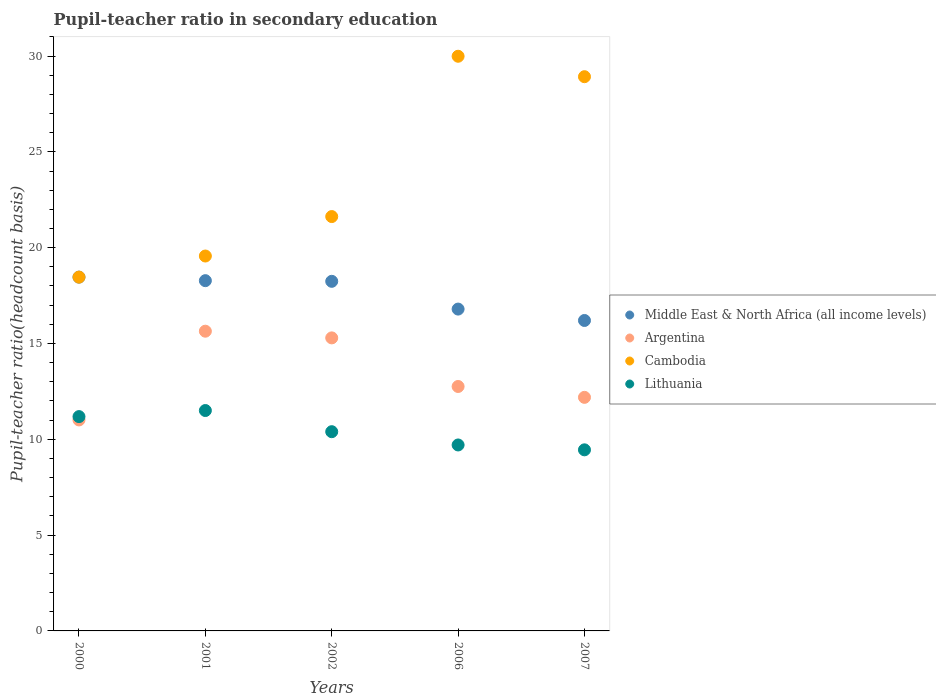How many different coloured dotlines are there?
Keep it short and to the point. 4. What is the pupil-teacher ratio in secondary education in Middle East & North Africa (all income levels) in 2001?
Keep it short and to the point. 18.28. Across all years, what is the maximum pupil-teacher ratio in secondary education in Lithuania?
Ensure brevity in your answer.  11.5. Across all years, what is the minimum pupil-teacher ratio in secondary education in Lithuania?
Keep it short and to the point. 9.45. In which year was the pupil-teacher ratio in secondary education in Cambodia minimum?
Provide a short and direct response. 2000. What is the total pupil-teacher ratio in secondary education in Cambodia in the graph?
Your response must be concise. 118.56. What is the difference between the pupil-teacher ratio in secondary education in Middle East & North Africa (all income levels) in 2002 and that in 2007?
Keep it short and to the point. 2.04. What is the difference between the pupil-teacher ratio in secondary education in Lithuania in 2001 and the pupil-teacher ratio in secondary education in Middle East & North Africa (all income levels) in 2000?
Your answer should be very brief. -6.96. What is the average pupil-teacher ratio in secondary education in Middle East & North Africa (all income levels) per year?
Offer a terse response. 17.6. In the year 2001, what is the difference between the pupil-teacher ratio in secondary education in Cambodia and pupil-teacher ratio in secondary education in Argentina?
Your response must be concise. 3.92. What is the ratio of the pupil-teacher ratio in secondary education in Lithuania in 2000 to that in 2007?
Offer a very short reply. 1.18. Is the difference between the pupil-teacher ratio in secondary education in Cambodia in 2000 and 2006 greater than the difference between the pupil-teacher ratio in secondary education in Argentina in 2000 and 2006?
Give a very brief answer. No. What is the difference between the highest and the second highest pupil-teacher ratio in secondary education in Middle East & North Africa (all income levels)?
Make the answer very short. 0.18. What is the difference between the highest and the lowest pupil-teacher ratio in secondary education in Lithuania?
Make the answer very short. 2.05. Is the sum of the pupil-teacher ratio in secondary education in Cambodia in 2000 and 2006 greater than the maximum pupil-teacher ratio in secondary education in Middle East & North Africa (all income levels) across all years?
Give a very brief answer. Yes. Is it the case that in every year, the sum of the pupil-teacher ratio in secondary education in Lithuania and pupil-teacher ratio in secondary education in Cambodia  is greater than the pupil-teacher ratio in secondary education in Argentina?
Offer a very short reply. Yes. Does the pupil-teacher ratio in secondary education in Middle East & North Africa (all income levels) monotonically increase over the years?
Offer a terse response. No. Is the pupil-teacher ratio in secondary education in Cambodia strictly greater than the pupil-teacher ratio in secondary education in Argentina over the years?
Provide a short and direct response. Yes. Is the pupil-teacher ratio in secondary education in Middle East & North Africa (all income levels) strictly less than the pupil-teacher ratio in secondary education in Argentina over the years?
Your response must be concise. No. How many dotlines are there?
Offer a terse response. 4. How many years are there in the graph?
Give a very brief answer. 5. What is the difference between two consecutive major ticks on the Y-axis?
Your answer should be compact. 5. Are the values on the major ticks of Y-axis written in scientific E-notation?
Provide a short and direct response. No. Does the graph contain grids?
Your answer should be compact. No. Where does the legend appear in the graph?
Your answer should be compact. Center right. How are the legend labels stacked?
Give a very brief answer. Vertical. What is the title of the graph?
Your answer should be compact. Pupil-teacher ratio in secondary education. Does "Mozambique" appear as one of the legend labels in the graph?
Offer a terse response. No. What is the label or title of the X-axis?
Your answer should be compact. Years. What is the label or title of the Y-axis?
Ensure brevity in your answer.  Pupil-teacher ratio(headcount basis). What is the Pupil-teacher ratio(headcount basis) of Middle East & North Africa (all income levels) in 2000?
Keep it short and to the point. 18.46. What is the Pupil-teacher ratio(headcount basis) of Argentina in 2000?
Provide a succinct answer. 11.01. What is the Pupil-teacher ratio(headcount basis) in Cambodia in 2000?
Provide a short and direct response. 18.46. What is the Pupil-teacher ratio(headcount basis) of Lithuania in 2000?
Make the answer very short. 11.18. What is the Pupil-teacher ratio(headcount basis) in Middle East & North Africa (all income levels) in 2001?
Provide a succinct answer. 18.28. What is the Pupil-teacher ratio(headcount basis) of Argentina in 2001?
Ensure brevity in your answer.  15.64. What is the Pupil-teacher ratio(headcount basis) in Cambodia in 2001?
Provide a succinct answer. 19.56. What is the Pupil-teacher ratio(headcount basis) of Lithuania in 2001?
Ensure brevity in your answer.  11.5. What is the Pupil-teacher ratio(headcount basis) of Middle East & North Africa (all income levels) in 2002?
Give a very brief answer. 18.24. What is the Pupil-teacher ratio(headcount basis) in Argentina in 2002?
Ensure brevity in your answer.  15.29. What is the Pupil-teacher ratio(headcount basis) in Cambodia in 2002?
Offer a terse response. 21.62. What is the Pupil-teacher ratio(headcount basis) in Lithuania in 2002?
Offer a terse response. 10.4. What is the Pupil-teacher ratio(headcount basis) of Middle East & North Africa (all income levels) in 2006?
Offer a terse response. 16.8. What is the Pupil-teacher ratio(headcount basis) in Argentina in 2006?
Provide a short and direct response. 12.76. What is the Pupil-teacher ratio(headcount basis) of Cambodia in 2006?
Keep it short and to the point. 29.99. What is the Pupil-teacher ratio(headcount basis) of Lithuania in 2006?
Provide a succinct answer. 9.7. What is the Pupil-teacher ratio(headcount basis) in Middle East & North Africa (all income levels) in 2007?
Provide a short and direct response. 16.2. What is the Pupil-teacher ratio(headcount basis) in Argentina in 2007?
Make the answer very short. 12.19. What is the Pupil-teacher ratio(headcount basis) of Cambodia in 2007?
Provide a succinct answer. 28.92. What is the Pupil-teacher ratio(headcount basis) of Lithuania in 2007?
Make the answer very short. 9.45. Across all years, what is the maximum Pupil-teacher ratio(headcount basis) in Middle East & North Africa (all income levels)?
Your response must be concise. 18.46. Across all years, what is the maximum Pupil-teacher ratio(headcount basis) of Argentina?
Offer a terse response. 15.64. Across all years, what is the maximum Pupil-teacher ratio(headcount basis) in Cambodia?
Provide a succinct answer. 29.99. Across all years, what is the maximum Pupil-teacher ratio(headcount basis) of Lithuania?
Your answer should be compact. 11.5. Across all years, what is the minimum Pupil-teacher ratio(headcount basis) of Middle East & North Africa (all income levels)?
Provide a short and direct response. 16.2. Across all years, what is the minimum Pupil-teacher ratio(headcount basis) of Argentina?
Make the answer very short. 11.01. Across all years, what is the minimum Pupil-teacher ratio(headcount basis) of Cambodia?
Make the answer very short. 18.46. Across all years, what is the minimum Pupil-teacher ratio(headcount basis) in Lithuania?
Ensure brevity in your answer.  9.45. What is the total Pupil-teacher ratio(headcount basis) in Middle East & North Africa (all income levels) in the graph?
Your answer should be compact. 87.98. What is the total Pupil-teacher ratio(headcount basis) in Argentina in the graph?
Your response must be concise. 66.89. What is the total Pupil-teacher ratio(headcount basis) of Cambodia in the graph?
Your response must be concise. 118.56. What is the total Pupil-teacher ratio(headcount basis) in Lithuania in the graph?
Make the answer very short. 52.24. What is the difference between the Pupil-teacher ratio(headcount basis) of Middle East & North Africa (all income levels) in 2000 and that in 2001?
Provide a succinct answer. 0.18. What is the difference between the Pupil-teacher ratio(headcount basis) of Argentina in 2000 and that in 2001?
Offer a very short reply. -4.63. What is the difference between the Pupil-teacher ratio(headcount basis) in Cambodia in 2000 and that in 2001?
Keep it short and to the point. -1.1. What is the difference between the Pupil-teacher ratio(headcount basis) in Lithuania in 2000 and that in 2001?
Your answer should be compact. -0.32. What is the difference between the Pupil-teacher ratio(headcount basis) in Middle East & North Africa (all income levels) in 2000 and that in 2002?
Your answer should be very brief. 0.22. What is the difference between the Pupil-teacher ratio(headcount basis) in Argentina in 2000 and that in 2002?
Your response must be concise. -4.28. What is the difference between the Pupil-teacher ratio(headcount basis) of Cambodia in 2000 and that in 2002?
Your answer should be compact. -3.16. What is the difference between the Pupil-teacher ratio(headcount basis) in Lithuania in 2000 and that in 2002?
Offer a terse response. 0.79. What is the difference between the Pupil-teacher ratio(headcount basis) in Middle East & North Africa (all income levels) in 2000 and that in 2006?
Offer a terse response. 1.67. What is the difference between the Pupil-teacher ratio(headcount basis) of Argentina in 2000 and that in 2006?
Your answer should be very brief. -1.75. What is the difference between the Pupil-teacher ratio(headcount basis) in Cambodia in 2000 and that in 2006?
Provide a short and direct response. -11.53. What is the difference between the Pupil-teacher ratio(headcount basis) of Lithuania in 2000 and that in 2006?
Your answer should be compact. 1.48. What is the difference between the Pupil-teacher ratio(headcount basis) of Middle East & North Africa (all income levels) in 2000 and that in 2007?
Your answer should be very brief. 2.26. What is the difference between the Pupil-teacher ratio(headcount basis) of Argentina in 2000 and that in 2007?
Your answer should be very brief. -1.18. What is the difference between the Pupil-teacher ratio(headcount basis) of Cambodia in 2000 and that in 2007?
Keep it short and to the point. -10.46. What is the difference between the Pupil-teacher ratio(headcount basis) in Lithuania in 2000 and that in 2007?
Ensure brevity in your answer.  1.73. What is the difference between the Pupil-teacher ratio(headcount basis) of Middle East & North Africa (all income levels) in 2001 and that in 2002?
Offer a very short reply. 0.03. What is the difference between the Pupil-teacher ratio(headcount basis) of Argentina in 2001 and that in 2002?
Provide a short and direct response. 0.35. What is the difference between the Pupil-teacher ratio(headcount basis) in Cambodia in 2001 and that in 2002?
Your answer should be compact. -2.06. What is the difference between the Pupil-teacher ratio(headcount basis) of Lithuania in 2001 and that in 2002?
Provide a short and direct response. 1.1. What is the difference between the Pupil-teacher ratio(headcount basis) in Middle East & North Africa (all income levels) in 2001 and that in 2006?
Make the answer very short. 1.48. What is the difference between the Pupil-teacher ratio(headcount basis) of Argentina in 2001 and that in 2006?
Your answer should be compact. 2.88. What is the difference between the Pupil-teacher ratio(headcount basis) of Cambodia in 2001 and that in 2006?
Give a very brief answer. -10.42. What is the difference between the Pupil-teacher ratio(headcount basis) of Lithuania in 2001 and that in 2006?
Your response must be concise. 1.8. What is the difference between the Pupil-teacher ratio(headcount basis) in Middle East & North Africa (all income levels) in 2001 and that in 2007?
Offer a very short reply. 2.08. What is the difference between the Pupil-teacher ratio(headcount basis) of Argentina in 2001 and that in 2007?
Give a very brief answer. 3.45. What is the difference between the Pupil-teacher ratio(headcount basis) in Cambodia in 2001 and that in 2007?
Make the answer very short. -9.36. What is the difference between the Pupil-teacher ratio(headcount basis) in Lithuania in 2001 and that in 2007?
Provide a short and direct response. 2.05. What is the difference between the Pupil-teacher ratio(headcount basis) in Middle East & North Africa (all income levels) in 2002 and that in 2006?
Offer a terse response. 1.45. What is the difference between the Pupil-teacher ratio(headcount basis) of Argentina in 2002 and that in 2006?
Your response must be concise. 2.54. What is the difference between the Pupil-teacher ratio(headcount basis) of Cambodia in 2002 and that in 2006?
Keep it short and to the point. -8.37. What is the difference between the Pupil-teacher ratio(headcount basis) in Lithuania in 2002 and that in 2006?
Your response must be concise. 0.69. What is the difference between the Pupil-teacher ratio(headcount basis) in Middle East & North Africa (all income levels) in 2002 and that in 2007?
Your answer should be compact. 2.04. What is the difference between the Pupil-teacher ratio(headcount basis) in Argentina in 2002 and that in 2007?
Offer a terse response. 3.1. What is the difference between the Pupil-teacher ratio(headcount basis) of Cambodia in 2002 and that in 2007?
Offer a very short reply. -7.3. What is the difference between the Pupil-teacher ratio(headcount basis) of Lithuania in 2002 and that in 2007?
Ensure brevity in your answer.  0.95. What is the difference between the Pupil-teacher ratio(headcount basis) in Middle East & North Africa (all income levels) in 2006 and that in 2007?
Give a very brief answer. 0.59. What is the difference between the Pupil-teacher ratio(headcount basis) of Argentina in 2006 and that in 2007?
Offer a very short reply. 0.57. What is the difference between the Pupil-teacher ratio(headcount basis) of Cambodia in 2006 and that in 2007?
Offer a terse response. 1.07. What is the difference between the Pupil-teacher ratio(headcount basis) in Lithuania in 2006 and that in 2007?
Keep it short and to the point. 0.25. What is the difference between the Pupil-teacher ratio(headcount basis) of Middle East & North Africa (all income levels) in 2000 and the Pupil-teacher ratio(headcount basis) of Argentina in 2001?
Your answer should be very brief. 2.82. What is the difference between the Pupil-teacher ratio(headcount basis) in Middle East & North Africa (all income levels) in 2000 and the Pupil-teacher ratio(headcount basis) in Cambodia in 2001?
Your answer should be very brief. -1.1. What is the difference between the Pupil-teacher ratio(headcount basis) in Middle East & North Africa (all income levels) in 2000 and the Pupil-teacher ratio(headcount basis) in Lithuania in 2001?
Provide a succinct answer. 6.96. What is the difference between the Pupil-teacher ratio(headcount basis) in Argentina in 2000 and the Pupil-teacher ratio(headcount basis) in Cambodia in 2001?
Offer a very short reply. -8.55. What is the difference between the Pupil-teacher ratio(headcount basis) in Argentina in 2000 and the Pupil-teacher ratio(headcount basis) in Lithuania in 2001?
Offer a terse response. -0.49. What is the difference between the Pupil-teacher ratio(headcount basis) in Cambodia in 2000 and the Pupil-teacher ratio(headcount basis) in Lithuania in 2001?
Give a very brief answer. 6.96. What is the difference between the Pupil-teacher ratio(headcount basis) of Middle East & North Africa (all income levels) in 2000 and the Pupil-teacher ratio(headcount basis) of Argentina in 2002?
Your answer should be very brief. 3.17. What is the difference between the Pupil-teacher ratio(headcount basis) of Middle East & North Africa (all income levels) in 2000 and the Pupil-teacher ratio(headcount basis) of Cambodia in 2002?
Offer a very short reply. -3.16. What is the difference between the Pupil-teacher ratio(headcount basis) in Middle East & North Africa (all income levels) in 2000 and the Pupil-teacher ratio(headcount basis) in Lithuania in 2002?
Make the answer very short. 8.07. What is the difference between the Pupil-teacher ratio(headcount basis) in Argentina in 2000 and the Pupil-teacher ratio(headcount basis) in Cambodia in 2002?
Provide a succinct answer. -10.61. What is the difference between the Pupil-teacher ratio(headcount basis) of Argentina in 2000 and the Pupil-teacher ratio(headcount basis) of Lithuania in 2002?
Make the answer very short. 0.61. What is the difference between the Pupil-teacher ratio(headcount basis) in Cambodia in 2000 and the Pupil-teacher ratio(headcount basis) in Lithuania in 2002?
Ensure brevity in your answer.  8.07. What is the difference between the Pupil-teacher ratio(headcount basis) in Middle East & North Africa (all income levels) in 2000 and the Pupil-teacher ratio(headcount basis) in Argentina in 2006?
Make the answer very short. 5.71. What is the difference between the Pupil-teacher ratio(headcount basis) in Middle East & North Africa (all income levels) in 2000 and the Pupil-teacher ratio(headcount basis) in Cambodia in 2006?
Keep it short and to the point. -11.53. What is the difference between the Pupil-teacher ratio(headcount basis) of Middle East & North Africa (all income levels) in 2000 and the Pupil-teacher ratio(headcount basis) of Lithuania in 2006?
Give a very brief answer. 8.76. What is the difference between the Pupil-teacher ratio(headcount basis) of Argentina in 2000 and the Pupil-teacher ratio(headcount basis) of Cambodia in 2006?
Offer a very short reply. -18.98. What is the difference between the Pupil-teacher ratio(headcount basis) of Argentina in 2000 and the Pupil-teacher ratio(headcount basis) of Lithuania in 2006?
Your answer should be compact. 1.31. What is the difference between the Pupil-teacher ratio(headcount basis) of Cambodia in 2000 and the Pupil-teacher ratio(headcount basis) of Lithuania in 2006?
Offer a terse response. 8.76. What is the difference between the Pupil-teacher ratio(headcount basis) of Middle East & North Africa (all income levels) in 2000 and the Pupil-teacher ratio(headcount basis) of Argentina in 2007?
Offer a very short reply. 6.27. What is the difference between the Pupil-teacher ratio(headcount basis) in Middle East & North Africa (all income levels) in 2000 and the Pupil-teacher ratio(headcount basis) in Cambodia in 2007?
Provide a succinct answer. -10.46. What is the difference between the Pupil-teacher ratio(headcount basis) in Middle East & North Africa (all income levels) in 2000 and the Pupil-teacher ratio(headcount basis) in Lithuania in 2007?
Provide a succinct answer. 9.01. What is the difference between the Pupil-teacher ratio(headcount basis) in Argentina in 2000 and the Pupil-teacher ratio(headcount basis) in Cambodia in 2007?
Keep it short and to the point. -17.91. What is the difference between the Pupil-teacher ratio(headcount basis) in Argentina in 2000 and the Pupil-teacher ratio(headcount basis) in Lithuania in 2007?
Provide a short and direct response. 1.56. What is the difference between the Pupil-teacher ratio(headcount basis) in Cambodia in 2000 and the Pupil-teacher ratio(headcount basis) in Lithuania in 2007?
Ensure brevity in your answer.  9.01. What is the difference between the Pupil-teacher ratio(headcount basis) in Middle East & North Africa (all income levels) in 2001 and the Pupil-teacher ratio(headcount basis) in Argentina in 2002?
Ensure brevity in your answer.  2.99. What is the difference between the Pupil-teacher ratio(headcount basis) in Middle East & North Africa (all income levels) in 2001 and the Pupil-teacher ratio(headcount basis) in Cambodia in 2002?
Offer a terse response. -3.34. What is the difference between the Pupil-teacher ratio(headcount basis) in Middle East & North Africa (all income levels) in 2001 and the Pupil-teacher ratio(headcount basis) in Lithuania in 2002?
Offer a terse response. 7.88. What is the difference between the Pupil-teacher ratio(headcount basis) in Argentina in 2001 and the Pupil-teacher ratio(headcount basis) in Cambodia in 2002?
Provide a short and direct response. -5.98. What is the difference between the Pupil-teacher ratio(headcount basis) in Argentina in 2001 and the Pupil-teacher ratio(headcount basis) in Lithuania in 2002?
Give a very brief answer. 5.24. What is the difference between the Pupil-teacher ratio(headcount basis) of Cambodia in 2001 and the Pupil-teacher ratio(headcount basis) of Lithuania in 2002?
Provide a short and direct response. 9.17. What is the difference between the Pupil-teacher ratio(headcount basis) in Middle East & North Africa (all income levels) in 2001 and the Pupil-teacher ratio(headcount basis) in Argentina in 2006?
Provide a short and direct response. 5.52. What is the difference between the Pupil-teacher ratio(headcount basis) in Middle East & North Africa (all income levels) in 2001 and the Pupil-teacher ratio(headcount basis) in Cambodia in 2006?
Provide a short and direct response. -11.71. What is the difference between the Pupil-teacher ratio(headcount basis) of Middle East & North Africa (all income levels) in 2001 and the Pupil-teacher ratio(headcount basis) of Lithuania in 2006?
Provide a succinct answer. 8.57. What is the difference between the Pupil-teacher ratio(headcount basis) of Argentina in 2001 and the Pupil-teacher ratio(headcount basis) of Cambodia in 2006?
Keep it short and to the point. -14.35. What is the difference between the Pupil-teacher ratio(headcount basis) of Argentina in 2001 and the Pupil-teacher ratio(headcount basis) of Lithuania in 2006?
Ensure brevity in your answer.  5.94. What is the difference between the Pupil-teacher ratio(headcount basis) of Cambodia in 2001 and the Pupil-teacher ratio(headcount basis) of Lithuania in 2006?
Provide a succinct answer. 9.86. What is the difference between the Pupil-teacher ratio(headcount basis) in Middle East & North Africa (all income levels) in 2001 and the Pupil-teacher ratio(headcount basis) in Argentina in 2007?
Your answer should be very brief. 6.09. What is the difference between the Pupil-teacher ratio(headcount basis) in Middle East & North Africa (all income levels) in 2001 and the Pupil-teacher ratio(headcount basis) in Cambodia in 2007?
Provide a succinct answer. -10.64. What is the difference between the Pupil-teacher ratio(headcount basis) of Middle East & North Africa (all income levels) in 2001 and the Pupil-teacher ratio(headcount basis) of Lithuania in 2007?
Offer a terse response. 8.83. What is the difference between the Pupil-teacher ratio(headcount basis) in Argentina in 2001 and the Pupil-teacher ratio(headcount basis) in Cambodia in 2007?
Offer a terse response. -13.28. What is the difference between the Pupil-teacher ratio(headcount basis) of Argentina in 2001 and the Pupil-teacher ratio(headcount basis) of Lithuania in 2007?
Offer a terse response. 6.19. What is the difference between the Pupil-teacher ratio(headcount basis) in Cambodia in 2001 and the Pupil-teacher ratio(headcount basis) in Lithuania in 2007?
Make the answer very short. 10.11. What is the difference between the Pupil-teacher ratio(headcount basis) of Middle East & North Africa (all income levels) in 2002 and the Pupil-teacher ratio(headcount basis) of Argentina in 2006?
Your answer should be very brief. 5.49. What is the difference between the Pupil-teacher ratio(headcount basis) in Middle East & North Africa (all income levels) in 2002 and the Pupil-teacher ratio(headcount basis) in Cambodia in 2006?
Ensure brevity in your answer.  -11.75. What is the difference between the Pupil-teacher ratio(headcount basis) of Middle East & North Africa (all income levels) in 2002 and the Pupil-teacher ratio(headcount basis) of Lithuania in 2006?
Your answer should be compact. 8.54. What is the difference between the Pupil-teacher ratio(headcount basis) of Argentina in 2002 and the Pupil-teacher ratio(headcount basis) of Cambodia in 2006?
Make the answer very short. -14.7. What is the difference between the Pupil-teacher ratio(headcount basis) in Argentina in 2002 and the Pupil-teacher ratio(headcount basis) in Lithuania in 2006?
Your answer should be compact. 5.59. What is the difference between the Pupil-teacher ratio(headcount basis) of Cambodia in 2002 and the Pupil-teacher ratio(headcount basis) of Lithuania in 2006?
Keep it short and to the point. 11.92. What is the difference between the Pupil-teacher ratio(headcount basis) of Middle East & North Africa (all income levels) in 2002 and the Pupil-teacher ratio(headcount basis) of Argentina in 2007?
Make the answer very short. 6.05. What is the difference between the Pupil-teacher ratio(headcount basis) in Middle East & North Africa (all income levels) in 2002 and the Pupil-teacher ratio(headcount basis) in Cambodia in 2007?
Offer a terse response. -10.68. What is the difference between the Pupil-teacher ratio(headcount basis) in Middle East & North Africa (all income levels) in 2002 and the Pupil-teacher ratio(headcount basis) in Lithuania in 2007?
Keep it short and to the point. 8.79. What is the difference between the Pupil-teacher ratio(headcount basis) of Argentina in 2002 and the Pupil-teacher ratio(headcount basis) of Cambodia in 2007?
Your response must be concise. -13.63. What is the difference between the Pupil-teacher ratio(headcount basis) of Argentina in 2002 and the Pupil-teacher ratio(headcount basis) of Lithuania in 2007?
Your response must be concise. 5.84. What is the difference between the Pupil-teacher ratio(headcount basis) of Cambodia in 2002 and the Pupil-teacher ratio(headcount basis) of Lithuania in 2007?
Ensure brevity in your answer.  12.17. What is the difference between the Pupil-teacher ratio(headcount basis) in Middle East & North Africa (all income levels) in 2006 and the Pupil-teacher ratio(headcount basis) in Argentina in 2007?
Keep it short and to the point. 4.61. What is the difference between the Pupil-teacher ratio(headcount basis) of Middle East & North Africa (all income levels) in 2006 and the Pupil-teacher ratio(headcount basis) of Cambodia in 2007?
Give a very brief answer. -12.13. What is the difference between the Pupil-teacher ratio(headcount basis) of Middle East & North Africa (all income levels) in 2006 and the Pupil-teacher ratio(headcount basis) of Lithuania in 2007?
Make the answer very short. 7.34. What is the difference between the Pupil-teacher ratio(headcount basis) of Argentina in 2006 and the Pupil-teacher ratio(headcount basis) of Cambodia in 2007?
Provide a succinct answer. -16.17. What is the difference between the Pupil-teacher ratio(headcount basis) in Argentina in 2006 and the Pupil-teacher ratio(headcount basis) in Lithuania in 2007?
Keep it short and to the point. 3.31. What is the difference between the Pupil-teacher ratio(headcount basis) of Cambodia in 2006 and the Pupil-teacher ratio(headcount basis) of Lithuania in 2007?
Your response must be concise. 20.54. What is the average Pupil-teacher ratio(headcount basis) of Middle East & North Africa (all income levels) per year?
Your response must be concise. 17.6. What is the average Pupil-teacher ratio(headcount basis) in Argentina per year?
Give a very brief answer. 13.38. What is the average Pupil-teacher ratio(headcount basis) in Cambodia per year?
Ensure brevity in your answer.  23.71. What is the average Pupil-teacher ratio(headcount basis) in Lithuania per year?
Provide a short and direct response. 10.45. In the year 2000, what is the difference between the Pupil-teacher ratio(headcount basis) of Middle East & North Africa (all income levels) and Pupil-teacher ratio(headcount basis) of Argentina?
Your answer should be very brief. 7.45. In the year 2000, what is the difference between the Pupil-teacher ratio(headcount basis) of Middle East & North Africa (all income levels) and Pupil-teacher ratio(headcount basis) of Cambodia?
Ensure brevity in your answer.  -0. In the year 2000, what is the difference between the Pupil-teacher ratio(headcount basis) in Middle East & North Africa (all income levels) and Pupil-teacher ratio(headcount basis) in Lithuania?
Your answer should be very brief. 7.28. In the year 2000, what is the difference between the Pupil-teacher ratio(headcount basis) of Argentina and Pupil-teacher ratio(headcount basis) of Cambodia?
Provide a short and direct response. -7.45. In the year 2000, what is the difference between the Pupil-teacher ratio(headcount basis) of Argentina and Pupil-teacher ratio(headcount basis) of Lithuania?
Offer a very short reply. -0.17. In the year 2000, what is the difference between the Pupil-teacher ratio(headcount basis) in Cambodia and Pupil-teacher ratio(headcount basis) in Lithuania?
Make the answer very short. 7.28. In the year 2001, what is the difference between the Pupil-teacher ratio(headcount basis) in Middle East & North Africa (all income levels) and Pupil-teacher ratio(headcount basis) in Argentina?
Offer a very short reply. 2.64. In the year 2001, what is the difference between the Pupil-teacher ratio(headcount basis) of Middle East & North Africa (all income levels) and Pupil-teacher ratio(headcount basis) of Cambodia?
Make the answer very short. -1.29. In the year 2001, what is the difference between the Pupil-teacher ratio(headcount basis) of Middle East & North Africa (all income levels) and Pupil-teacher ratio(headcount basis) of Lithuania?
Your answer should be very brief. 6.78. In the year 2001, what is the difference between the Pupil-teacher ratio(headcount basis) in Argentina and Pupil-teacher ratio(headcount basis) in Cambodia?
Your answer should be very brief. -3.92. In the year 2001, what is the difference between the Pupil-teacher ratio(headcount basis) in Argentina and Pupil-teacher ratio(headcount basis) in Lithuania?
Offer a very short reply. 4.14. In the year 2001, what is the difference between the Pupil-teacher ratio(headcount basis) in Cambodia and Pupil-teacher ratio(headcount basis) in Lithuania?
Make the answer very short. 8.06. In the year 2002, what is the difference between the Pupil-teacher ratio(headcount basis) of Middle East & North Africa (all income levels) and Pupil-teacher ratio(headcount basis) of Argentina?
Provide a short and direct response. 2.95. In the year 2002, what is the difference between the Pupil-teacher ratio(headcount basis) of Middle East & North Africa (all income levels) and Pupil-teacher ratio(headcount basis) of Cambodia?
Offer a very short reply. -3.38. In the year 2002, what is the difference between the Pupil-teacher ratio(headcount basis) of Middle East & North Africa (all income levels) and Pupil-teacher ratio(headcount basis) of Lithuania?
Provide a succinct answer. 7.85. In the year 2002, what is the difference between the Pupil-teacher ratio(headcount basis) of Argentina and Pupil-teacher ratio(headcount basis) of Cambodia?
Your answer should be compact. -6.33. In the year 2002, what is the difference between the Pupil-teacher ratio(headcount basis) of Argentina and Pupil-teacher ratio(headcount basis) of Lithuania?
Offer a terse response. 4.9. In the year 2002, what is the difference between the Pupil-teacher ratio(headcount basis) of Cambodia and Pupil-teacher ratio(headcount basis) of Lithuania?
Ensure brevity in your answer.  11.23. In the year 2006, what is the difference between the Pupil-teacher ratio(headcount basis) in Middle East & North Africa (all income levels) and Pupil-teacher ratio(headcount basis) in Argentina?
Provide a short and direct response. 4.04. In the year 2006, what is the difference between the Pupil-teacher ratio(headcount basis) of Middle East & North Africa (all income levels) and Pupil-teacher ratio(headcount basis) of Cambodia?
Your response must be concise. -13.19. In the year 2006, what is the difference between the Pupil-teacher ratio(headcount basis) of Middle East & North Africa (all income levels) and Pupil-teacher ratio(headcount basis) of Lithuania?
Offer a terse response. 7.09. In the year 2006, what is the difference between the Pupil-teacher ratio(headcount basis) in Argentina and Pupil-teacher ratio(headcount basis) in Cambodia?
Offer a terse response. -17.23. In the year 2006, what is the difference between the Pupil-teacher ratio(headcount basis) of Argentina and Pupil-teacher ratio(headcount basis) of Lithuania?
Your answer should be compact. 3.05. In the year 2006, what is the difference between the Pupil-teacher ratio(headcount basis) in Cambodia and Pupil-teacher ratio(headcount basis) in Lithuania?
Offer a very short reply. 20.28. In the year 2007, what is the difference between the Pupil-teacher ratio(headcount basis) of Middle East & North Africa (all income levels) and Pupil-teacher ratio(headcount basis) of Argentina?
Ensure brevity in your answer.  4.01. In the year 2007, what is the difference between the Pupil-teacher ratio(headcount basis) of Middle East & North Africa (all income levels) and Pupil-teacher ratio(headcount basis) of Cambodia?
Make the answer very short. -12.72. In the year 2007, what is the difference between the Pupil-teacher ratio(headcount basis) in Middle East & North Africa (all income levels) and Pupil-teacher ratio(headcount basis) in Lithuania?
Keep it short and to the point. 6.75. In the year 2007, what is the difference between the Pupil-teacher ratio(headcount basis) of Argentina and Pupil-teacher ratio(headcount basis) of Cambodia?
Give a very brief answer. -16.73. In the year 2007, what is the difference between the Pupil-teacher ratio(headcount basis) of Argentina and Pupil-teacher ratio(headcount basis) of Lithuania?
Offer a terse response. 2.74. In the year 2007, what is the difference between the Pupil-teacher ratio(headcount basis) in Cambodia and Pupil-teacher ratio(headcount basis) in Lithuania?
Provide a short and direct response. 19.47. What is the ratio of the Pupil-teacher ratio(headcount basis) of Argentina in 2000 to that in 2001?
Provide a succinct answer. 0.7. What is the ratio of the Pupil-teacher ratio(headcount basis) of Cambodia in 2000 to that in 2001?
Make the answer very short. 0.94. What is the ratio of the Pupil-teacher ratio(headcount basis) in Lithuania in 2000 to that in 2001?
Offer a very short reply. 0.97. What is the ratio of the Pupil-teacher ratio(headcount basis) in Argentina in 2000 to that in 2002?
Your response must be concise. 0.72. What is the ratio of the Pupil-teacher ratio(headcount basis) of Cambodia in 2000 to that in 2002?
Make the answer very short. 0.85. What is the ratio of the Pupil-teacher ratio(headcount basis) of Lithuania in 2000 to that in 2002?
Offer a terse response. 1.08. What is the ratio of the Pupil-teacher ratio(headcount basis) of Middle East & North Africa (all income levels) in 2000 to that in 2006?
Give a very brief answer. 1.1. What is the ratio of the Pupil-teacher ratio(headcount basis) in Argentina in 2000 to that in 2006?
Ensure brevity in your answer.  0.86. What is the ratio of the Pupil-teacher ratio(headcount basis) of Cambodia in 2000 to that in 2006?
Provide a succinct answer. 0.62. What is the ratio of the Pupil-teacher ratio(headcount basis) of Lithuania in 2000 to that in 2006?
Offer a terse response. 1.15. What is the ratio of the Pupil-teacher ratio(headcount basis) of Middle East & North Africa (all income levels) in 2000 to that in 2007?
Provide a succinct answer. 1.14. What is the ratio of the Pupil-teacher ratio(headcount basis) of Argentina in 2000 to that in 2007?
Provide a short and direct response. 0.9. What is the ratio of the Pupil-teacher ratio(headcount basis) in Cambodia in 2000 to that in 2007?
Make the answer very short. 0.64. What is the ratio of the Pupil-teacher ratio(headcount basis) in Lithuania in 2000 to that in 2007?
Offer a terse response. 1.18. What is the ratio of the Pupil-teacher ratio(headcount basis) in Argentina in 2001 to that in 2002?
Give a very brief answer. 1.02. What is the ratio of the Pupil-teacher ratio(headcount basis) in Cambodia in 2001 to that in 2002?
Provide a succinct answer. 0.9. What is the ratio of the Pupil-teacher ratio(headcount basis) of Lithuania in 2001 to that in 2002?
Provide a succinct answer. 1.11. What is the ratio of the Pupil-teacher ratio(headcount basis) of Middle East & North Africa (all income levels) in 2001 to that in 2006?
Give a very brief answer. 1.09. What is the ratio of the Pupil-teacher ratio(headcount basis) of Argentina in 2001 to that in 2006?
Provide a short and direct response. 1.23. What is the ratio of the Pupil-teacher ratio(headcount basis) of Cambodia in 2001 to that in 2006?
Your answer should be very brief. 0.65. What is the ratio of the Pupil-teacher ratio(headcount basis) of Lithuania in 2001 to that in 2006?
Your response must be concise. 1.19. What is the ratio of the Pupil-teacher ratio(headcount basis) in Middle East & North Africa (all income levels) in 2001 to that in 2007?
Your answer should be compact. 1.13. What is the ratio of the Pupil-teacher ratio(headcount basis) of Argentina in 2001 to that in 2007?
Keep it short and to the point. 1.28. What is the ratio of the Pupil-teacher ratio(headcount basis) of Cambodia in 2001 to that in 2007?
Your answer should be compact. 0.68. What is the ratio of the Pupil-teacher ratio(headcount basis) of Lithuania in 2001 to that in 2007?
Offer a terse response. 1.22. What is the ratio of the Pupil-teacher ratio(headcount basis) of Middle East & North Africa (all income levels) in 2002 to that in 2006?
Your answer should be very brief. 1.09. What is the ratio of the Pupil-teacher ratio(headcount basis) in Argentina in 2002 to that in 2006?
Offer a very short reply. 1.2. What is the ratio of the Pupil-teacher ratio(headcount basis) in Cambodia in 2002 to that in 2006?
Make the answer very short. 0.72. What is the ratio of the Pupil-teacher ratio(headcount basis) in Lithuania in 2002 to that in 2006?
Your answer should be very brief. 1.07. What is the ratio of the Pupil-teacher ratio(headcount basis) of Middle East & North Africa (all income levels) in 2002 to that in 2007?
Your response must be concise. 1.13. What is the ratio of the Pupil-teacher ratio(headcount basis) of Argentina in 2002 to that in 2007?
Give a very brief answer. 1.25. What is the ratio of the Pupil-teacher ratio(headcount basis) of Cambodia in 2002 to that in 2007?
Keep it short and to the point. 0.75. What is the ratio of the Pupil-teacher ratio(headcount basis) of Lithuania in 2002 to that in 2007?
Your answer should be compact. 1.1. What is the ratio of the Pupil-teacher ratio(headcount basis) in Middle East & North Africa (all income levels) in 2006 to that in 2007?
Offer a terse response. 1.04. What is the ratio of the Pupil-teacher ratio(headcount basis) in Argentina in 2006 to that in 2007?
Give a very brief answer. 1.05. What is the ratio of the Pupil-teacher ratio(headcount basis) in Cambodia in 2006 to that in 2007?
Make the answer very short. 1.04. What is the ratio of the Pupil-teacher ratio(headcount basis) in Lithuania in 2006 to that in 2007?
Make the answer very short. 1.03. What is the difference between the highest and the second highest Pupil-teacher ratio(headcount basis) in Middle East & North Africa (all income levels)?
Give a very brief answer. 0.18. What is the difference between the highest and the second highest Pupil-teacher ratio(headcount basis) in Argentina?
Your response must be concise. 0.35. What is the difference between the highest and the second highest Pupil-teacher ratio(headcount basis) in Cambodia?
Give a very brief answer. 1.07. What is the difference between the highest and the second highest Pupil-teacher ratio(headcount basis) of Lithuania?
Ensure brevity in your answer.  0.32. What is the difference between the highest and the lowest Pupil-teacher ratio(headcount basis) in Middle East & North Africa (all income levels)?
Keep it short and to the point. 2.26. What is the difference between the highest and the lowest Pupil-teacher ratio(headcount basis) of Argentina?
Offer a very short reply. 4.63. What is the difference between the highest and the lowest Pupil-teacher ratio(headcount basis) of Cambodia?
Your response must be concise. 11.53. What is the difference between the highest and the lowest Pupil-teacher ratio(headcount basis) in Lithuania?
Your answer should be very brief. 2.05. 